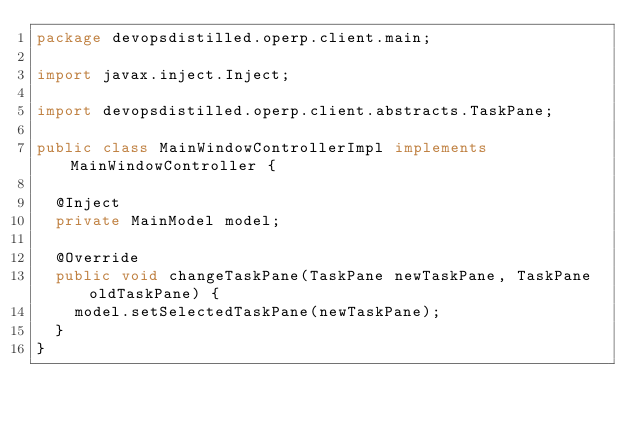<code> <loc_0><loc_0><loc_500><loc_500><_Java_>package devopsdistilled.operp.client.main;

import javax.inject.Inject;

import devopsdistilled.operp.client.abstracts.TaskPane;

public class MainWindowControllerImpl implements MainWindowController {

	@Inject
	private MainModel model;

	@Override
	public void changeTaskPane(TaskPane newTaskPane, TaskPane oldTaskPane) {
		model.setSelectedTaskPane(newTaskPane);
	}
}
</code> 